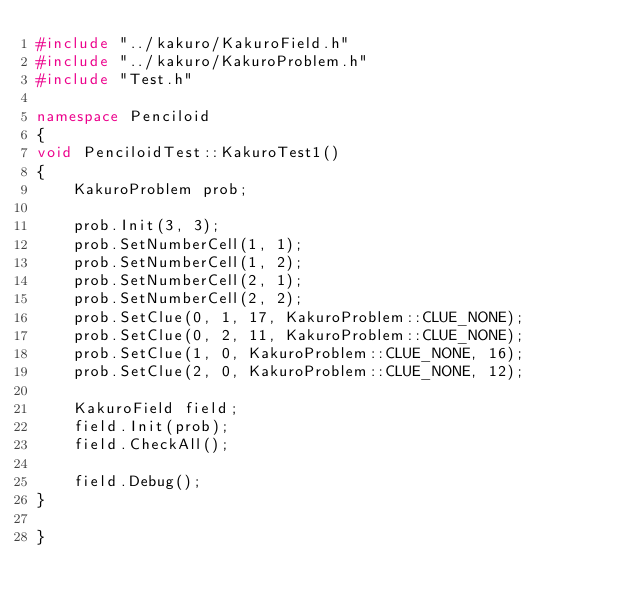<code> <loc_0><loc_0><loc_500><loc_500><_C++_>#include "../kakuro/KakuroField.h"
#include "../kakuro/KakuroProblem.h"
#include "Test.h"

namespace Penciloid
{
void PenciloidTest::KakuroTest1()
{
	KakuroProblem prob;

	prob.Init(3, 3);
	prob.SetNumberCell(1, 1);
	prob.SetNumberCell(1, 2);
	prob.SetNumberCell(2, 1);
	prob.SetNumberCell(2, 2);
	prob.SetClue(0, 1, 17, KakuroProblem::CLUE_NONE);
	prob.SetClue(0, 2, 11, KakuroProblem::CLUE_NONE);
	prob.SetClue(1, 0, KakuroProblem::CLUE_NONE, 16);
	prob.SetClue(2, 0, KakuroProblem::CLUE_NONE, 12);

	KakuroField field;
	field.Init(prob);
	field.CheckAll();

	field.Debug();
}

}
</code> 